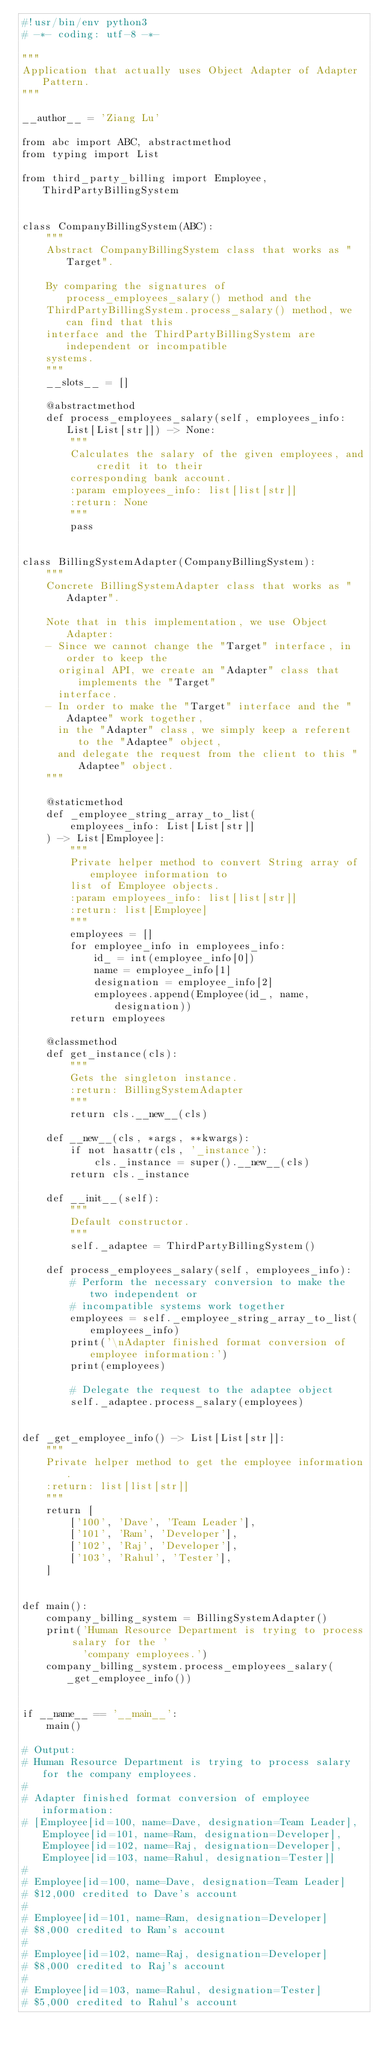Convert code to text. <code><loc_0><loc_0><loc_500><loc_500><_Python_>#!usr/bin/env python3
# -*- coding: utf-8 -*-

"""
Application that actually uses Object Adapter of Adapter Pattern.
"""

__author__ = 'Ziang Lu'

from abc import ABC, abstractmethod
from typing import List

from third_party_billing import Employee, ThirdPartyBillingSystem


class CompanyBillingSystem(ABC):
    """
    Abstract CompanyBillingSystem class that works as "Target".

    By comparing the signatures of process_employees_salary() method and the
    ThirdPartyBillingSystem.process_salary() method, we can find that this
    interface and the ThirdPartyBillingSystem are independent or incompatible
    systems.
    """
    __slots__ = []

    @abstractmethod
    def process_employees_salary(self, employees_info: List[List[str]]) -> None:
        """
        Calculates the salary of the given employees, and credit it to their
        corresponding bank account.
        :param employees_info: list[list[str]]
        :return: None
        """
        pass


class BillingSystemAdapter(CompanyBillingSystem):
    """
    Concrete BillingSystemAdapter class that works as "Adapter".

    Note that in this implementation, we use Object Adapter:
    - Since we cannot change the "Target" interface, in order to keep the
      original API, we create an "Adapter" class that implements the "Target"
      interface.
    - In order to make the "Target" interface and the "Adaptee" work together,
      in the "Adapter" class, we simply keep a referent to the "Adaptee" object,
      and delegate the request from the client to this "Adaptee" object.
    """

    @staticmethod
    def _employee_string_array_to_list(
        employees_info: List[List[str]]
    ) -> List[Employee]:
        """
        Private helper method to convert String array of employee information to
        list of Employee objects.
        :param employees_info: list[list[str]]
        :return: list[Employee]
        """
        employees = []
        for employee_info in employees_info:
            id_ = int(employee_info[0])
            name = employee_info[1]
            designation = employee_info[2]
            employees.append(Employee(id_, name, designation))
        return employees

    @classmethod
    def get_instance(cls):
        """
        Gets the singleton instance.
        :return: BillingSystemAdapter
        """
        return cls.__new__(cls)

    def __new__(cls, *args, **kwargs):
        if not hasattr(cls, '_instance'):
            cls._instance = super().__new__(cls)
        return cls._instance

    def __init__(self):
        """
        Default constructor.
        """
        self._adaptee = ThirdPartyBillingSystem()

    def process_employees_salary(self, employees_info):
        # Perform the necessary conversion to make the two independent or
        # incompatible systems work together
        employees = self._employee_string_array_to_list(employees_info)
        print('\nAdapter finished format conversion of employee information:')
        print(employees)

        # Delegate the request to the adaptee object
        self._adaptee.process_salary(employees)


def _get_employee_info() -> List[List[str]]:
    """
    Private helper method to get the employee information.
    :return: list[list[str]]
    """
    return [
        ['100', 'Dave', 'Team Leader'],
        ['101', 'Ram', 'Developer'],
        ['102', 'Raj', 'Developer'],
        ['103', 'Rahul', 'Tester'],
    ]


def main():
    company_billing_system = BillingSystemAdapter()
    print('Human Resource Department is trying to process salary for the '
          'company employees.')
    company_billing_system.process_employees_salary(_get_employee_info())


if __name__ == '__main__':
    main()

# Output:
# Human Resource Department is trying to process salary for the company employees.
#
# Adapter finished format conversion of employee information:
# [Employee[id=100, name=Dave, designation=Team Leader], Employee[id=101, name=Ram, designation=Developer], Employee[id=102, name=Raj, designation=Developer], Employee[id=103, name=Rahul, designation=Tester]]
#
# Employee[id=100, name=Dave, designation=Team Leader]
# $12,000 credited to Dave's account
#
# Employee[id=101, name=Ram, designation=Developer]
# $8,000 credited to Ram's account
#
# Employee[id=102, name=Raj, designation=Developer]
# $8,000 credited to Raj's account
#
# Employee[id=103, name=Rahul, designation=Tester]
# $5,000 credited to Rahul's account
</code> 